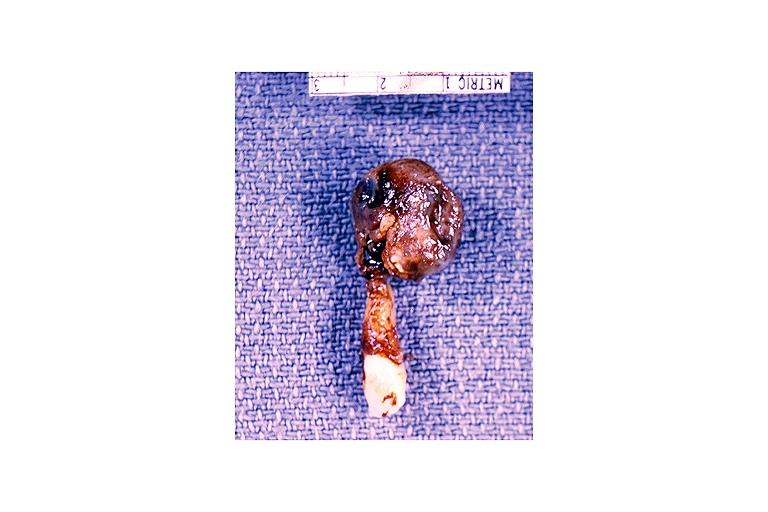does this image show radicular cyst?
Answer the question using a single word or phrase. Yes 